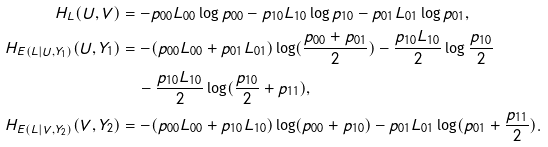<formula> <loc_0><loc_0><loc_500><loc_500>H _ { L } ( U , V ) & = - p _ { 0 0 } L _ { 0 0 } \log p _ { 0 0 } - p _ { 1 0 } L _ { 1 0 } \log p _ { 1 0 } - p _ { 0 1 } L _ { 0 1 } \log p _ { 0 1 } , \\ H _ { E ( L | U , Y _ { 1 } ) } ( U , Y _ { 1 } ) & = - ( p _ { 0 0 } L _ { 0 0 } + p _ { 0 1 } L _ { 0 1 } ) \log ( \frac { p _ { 0 0 } + p _ { 0 1 } } { 2 } ) - \frac { p _ { 1 0 } L _ { 1 0 } } { 2 } \log \frac { p _ { 1 0 } } { 2 } \\ & \quad - \frac { p _ { 1 0 } L _ { 1 0 } } { 2 } \log ( \frac { p _ { 1 0 } } { 2 } + p _ { 1 1 } ) , \\ H _ { E ( L | V , Y _ { 2 } ) } ( V , Y _ { 2 } ) & = - ( p _ { 0 0 } L _ { 0 0 } + p _ { 1 0 } L _ { 1 0 } ) \log ( p _ { 0 0 } + p _ { 1 0 } ) - p _ { 0 1 } L _ { 0 1 } \log ( p _ { 0 1 } + \frac { p _ { 1 1 } } { 2 } ) .</formula> 